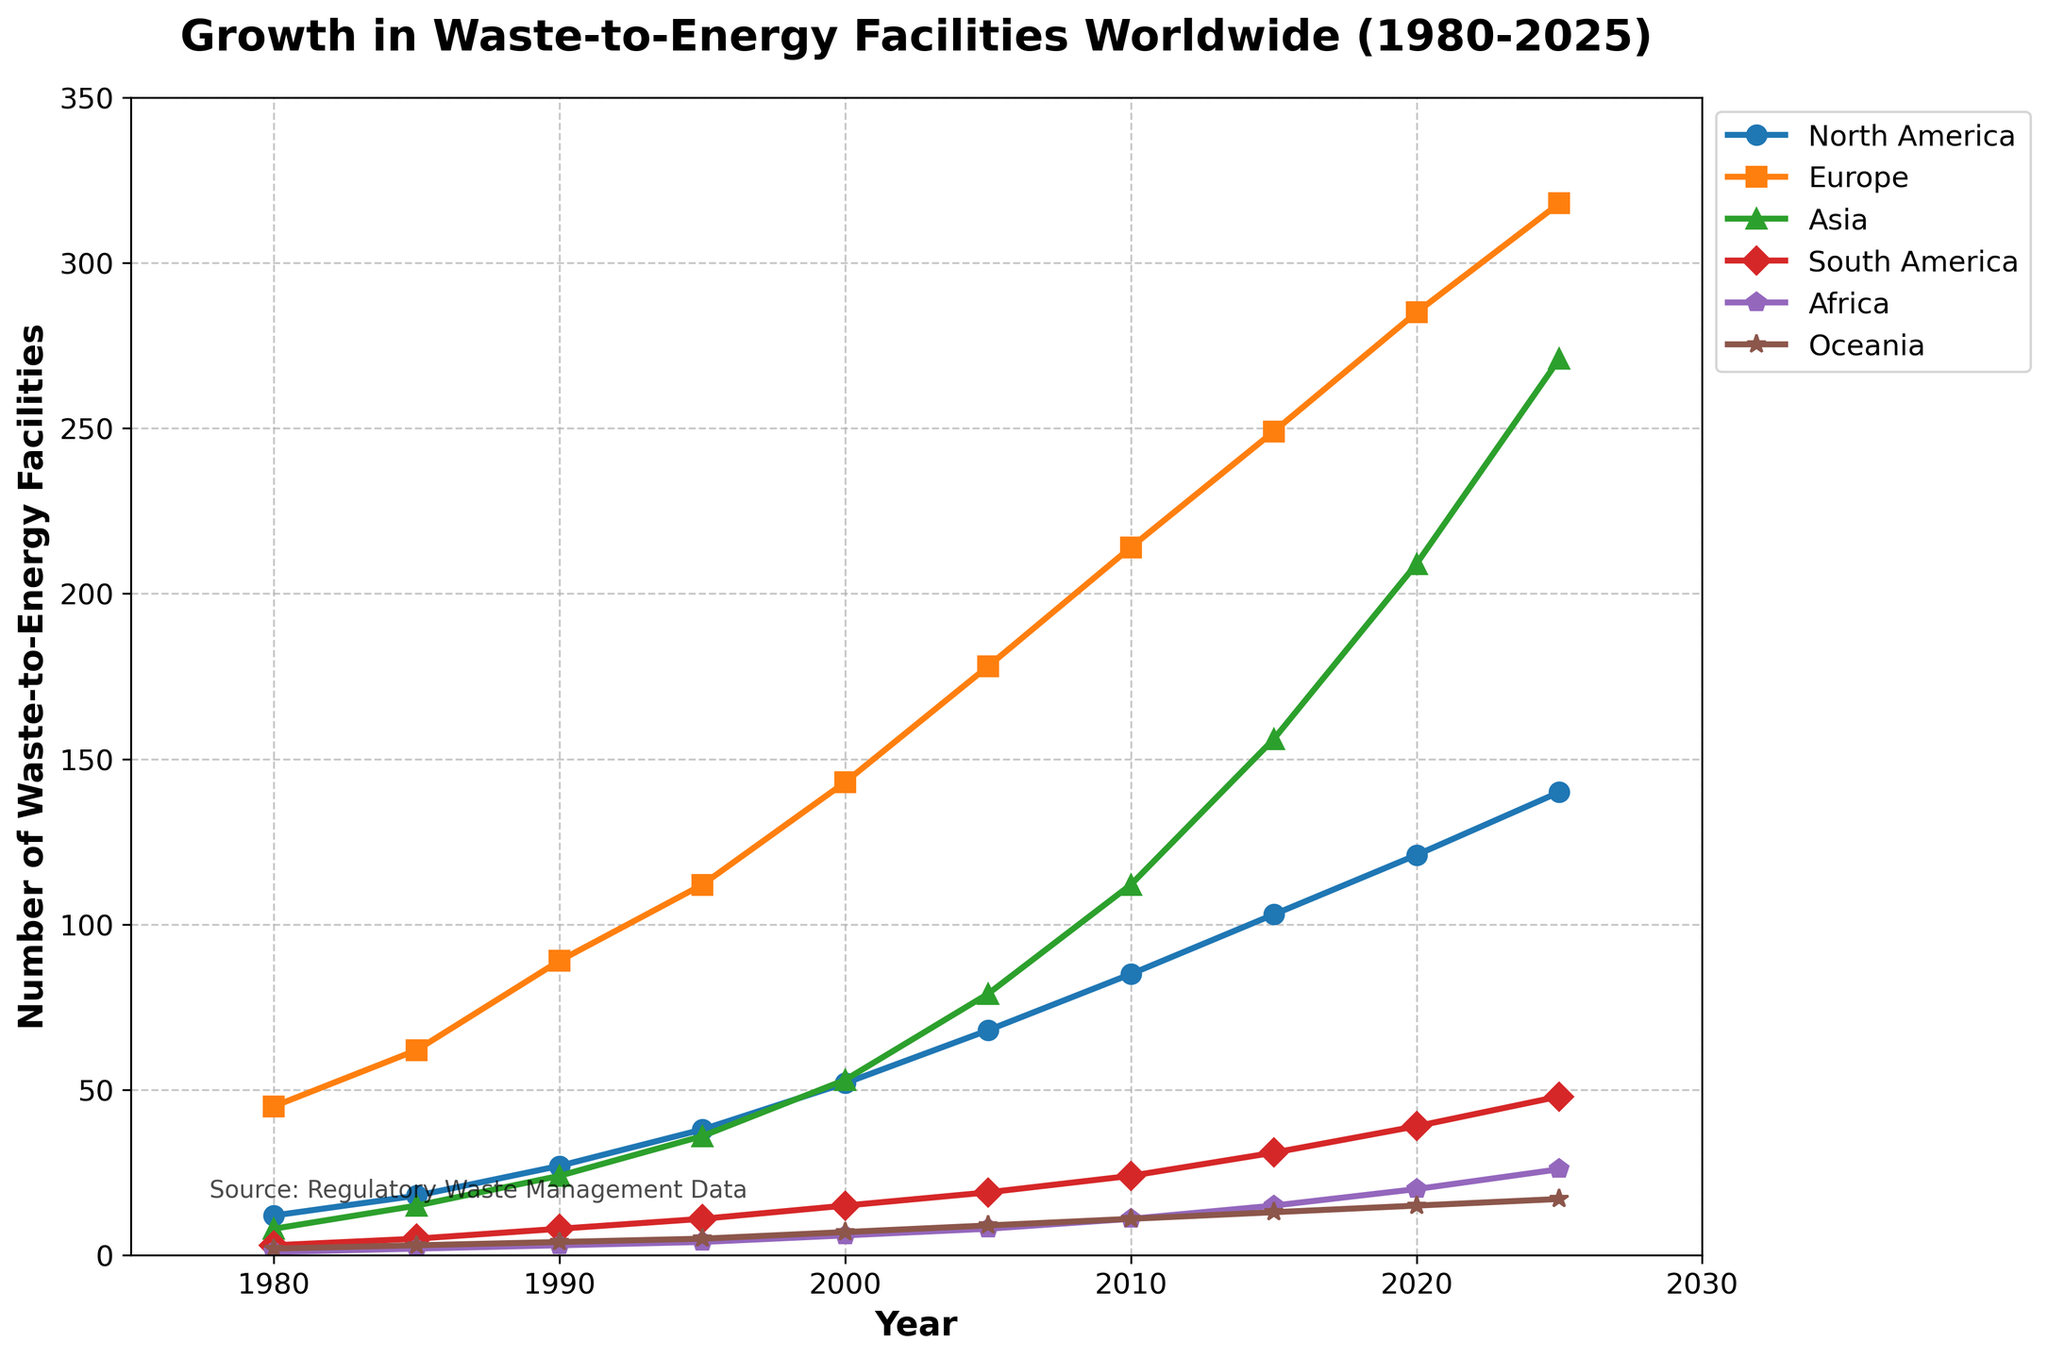How many waste-to-energy facilities were there in Europe and Asia combined in 2000? In 2000, Europe had 143 facilities and Asia had 53 facilities. Adding these together gives 143 + 53 = 196.
Answer: 196 Between which two years did North America see the highest increase in the number of waste-to-energy facilities? To determine this, we look at the differences between consecutive years for North America: 1980-1985: 6, 1985-1990: 9, 1990-1995: 11, 1995-2000: 14, 2000-2005: 16, 2005-2010: 17, 2010-2015: 18, 2015-2020: 18, 2020-2025: 19. The highest increase is between 2020 and 2025.
Answer: 2020-2025 Which continent had the smallest growth in the number of waste-to-energy facilities from 1980 to 2025? To find the smallest growth, we subtract the number of facilities in 1980 from the number in 2025 for each continent. North America: 140 - 12 = 128, Europe: 318 - 45 = 273, Asia: 271 - 8 = 263, South America: 48 - 3 = 45, Africa: 26 - 1 = 25, Oceania: 17 - 2 = 15. Oceania had the smallest growth.
Answer: Oceania In 2015, which continent had more waste-to-energy facilities: North America or Asia, and how many more? In 2015, North America had 103 facilities and Asia had 156 facilities. Asia had more, and the difference is 156 - 103 = 53.
Answer: Asia, 53 more Calculate the average number of waste-to-energy facilities in South America between 1980 and 2025. The number of facilities in South America for each year provided are: 1980: 3, 1985: 5, 1990: 8, 1995: 11, 2000: 15, 2005: 19, 2010: 24, 2015: 31, 2020: 39, 2025: 48. Adding these gives 3 + 5 + 8 + 11 + 15 + 19 + 24 + 31 + 39 + 48 = 203. Dividing by 10 (number of data points) gives 203 / 10 = 20.3.
Answer: 20.3 Which continent has consistently had the highest number of waste-to-energy facilities since 1980? By analyzing the data for each year, Europe has the highest number of facilities consistently from 1980 to 2025.
Answer: Europe What is the total number of waste-to-energy facilities worldwide in 2025? To find the total, we sum the number of facilities for each continent in 2025: North America: 140, Europe: 318, Asia: 271, South America: 48, Africa: 26, Oceania: 17. Adding these gives 140 + 318 + 271 + 48 + 26 + 17 = 820.
Answer: 820 Which continent experienced the largest increase in waste-to-energy facilities between 2000 and 2020? First, find the increase for each continent: North America: 121 - 52 = 69, Europe: 285 - 143 = 142, Asia: 209 - 53 = 156, South America: 39 - 15 = 24, Africa: 20 - 6 = 14, Oceania: 15 - 7 = 8. Asia experienced the largest increase (156).
Answer: Asia How many more waste-to-energy facilities does Africa need to reach the count of Oceania in 2025? In 2025, Africa has 26 facilities and Oceania has 17. Since Africa already has more than Oceania, the answer is 0.
Answer: 0 